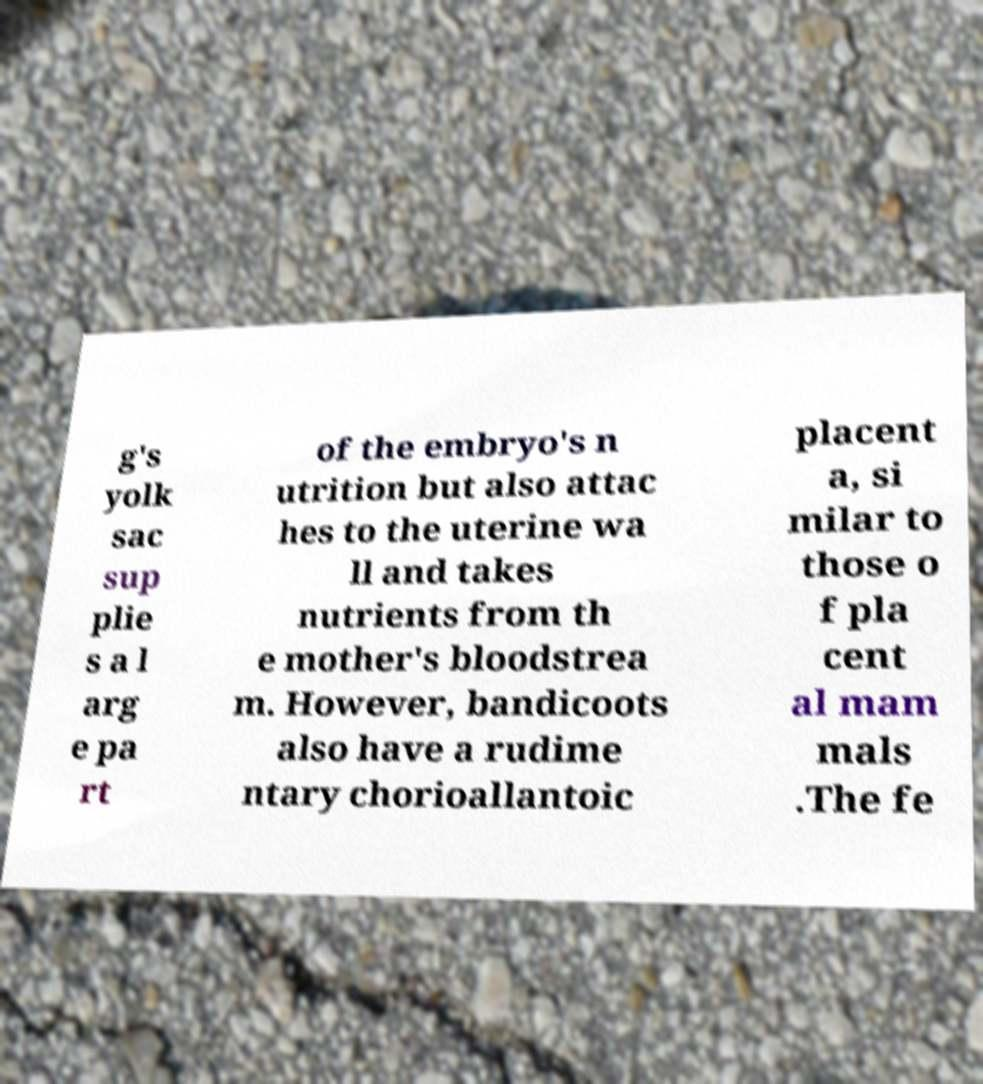There's text embedded in this image that I need extracted. Can you transcribe it verbatim? g's yolk sac sup plie s a l arg e pa rt of the embryo's n utrition but also attac hes to the uterine wa ll and takes nutrients from th e mother's bloodstrea m. However, bandicoots also have a rudime ntary chorioallantoic placent a, si milar to those o f pla cent al mam mals .The fe 